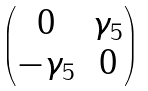<formula> <loc_0><loc_0><loc_500><loc_500>\begin{pmatrix} 0 & \gamma _ { 5 } \\ - \gamma _ { 5 } & 0 \end{pmatrix}</formula> 